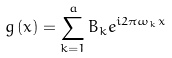<formula> <loc_0><loc_0><loc_500><loc_500>g \left ( x \right ) = \sum _ { k = 1 } ^ { a } B _ { k } e ^ { i 2 \pi \omega _ { k } x }</formula> 